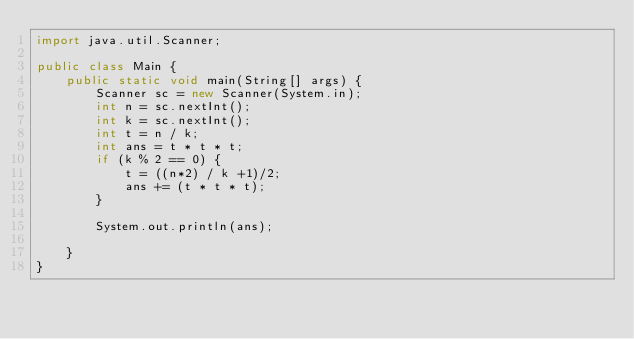<code> <loc_0><loc_0><loc_500><loc_500><_Java_>import java.util.Scanner;

public class Main {
    public static void main(String[] args) {
        Scanner sc = new Scanner(System.in);
        int n = sc.nextInt();
        int k = sc.nextInt();
        int t = n / k;
        int ans = t * t * t;
        if (k % 2 == 0) {
            t = ((n*2) / k +1)/2;
            ans += (t * t * t);
        }

        System.out.println(ans);

    }
}</code> 